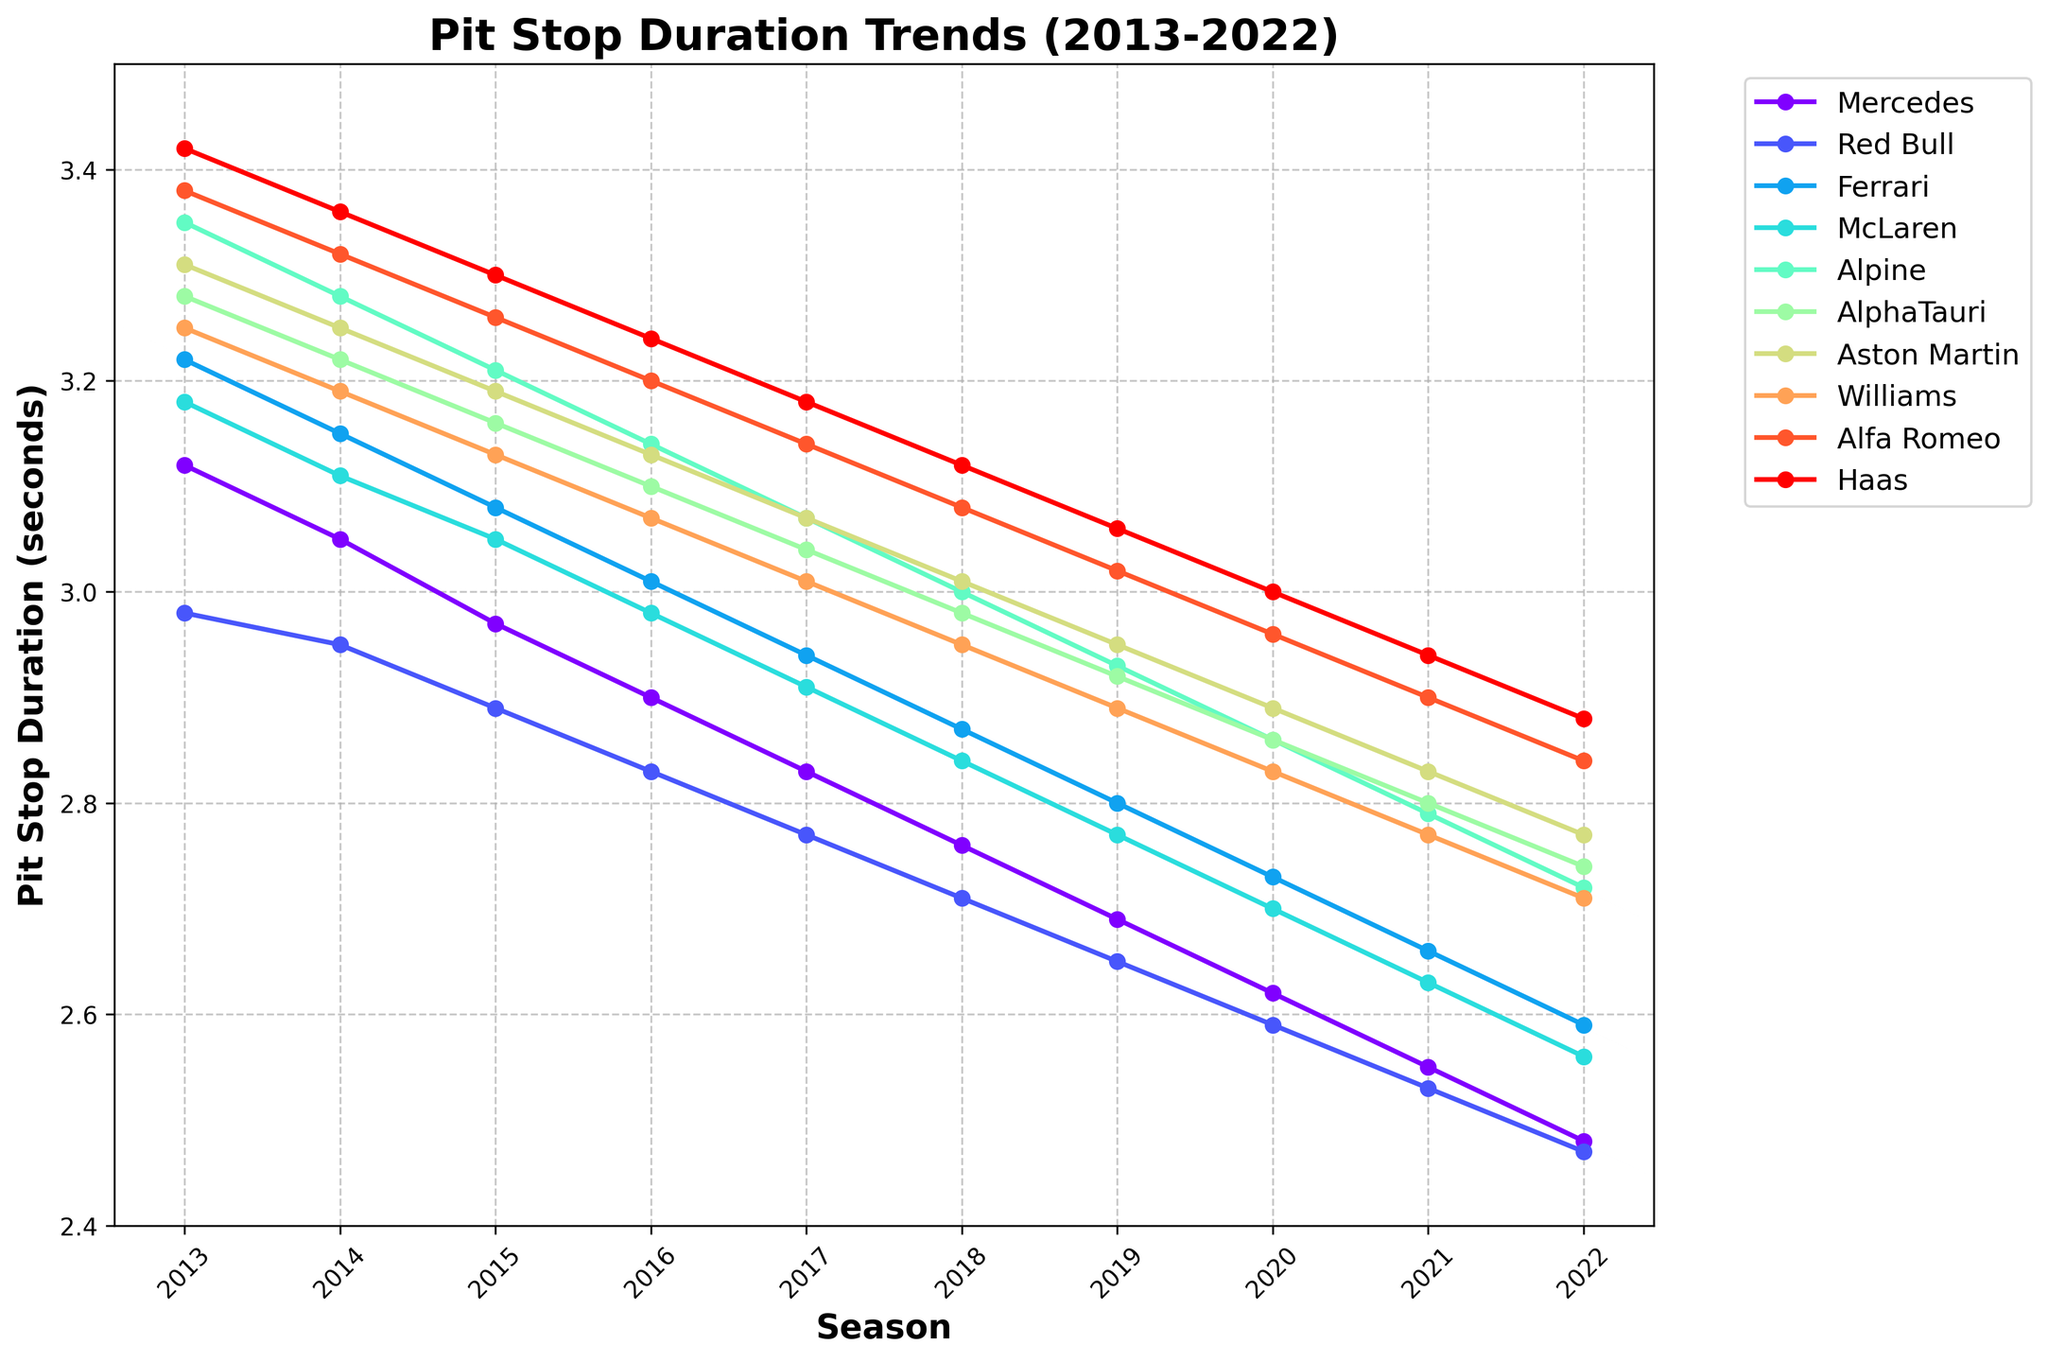Which team had the fastest pit stop duration in 2022? The fastest pit stop duration is identified by the lowest value in 2022. By examining the last entries for each team, it's clear that Red Bull has the lowest value of 2.47 seconds.
Answer: Red Bull How did Ferrari's pit stop duration change from 2013 to 2022? To find the change, subtract Ferrari's 2022 pit stop duration from its 2013 pit stop duration: 3.22 - 2.59 = 0.63 seconds.
Answer: 0.63 seconds Which team showed the greatest improvement in pit stop duration over the 10 seasons? Improvement is measured by the decrease in pit stop duration from 2013 to 2022. Calculate the difference for each team and find the largest: 
Mercedes: 3.12 - 2.48 = 0.64
Red Bull: 2.98 - 2.47 = 0.51
Ferrari: 3.22 - 2.59 = 0.63
McLaren: 3.18 - 2.56 = 0.62
Alpine: 3.35 - 2.72 = 0.63
AlphaTauri: 3.28 - 2.74 = 0.54
Aston Martin: 3.31 - 2.77 = 0.54
Williams: 3.25 - 2.71 = 0.54
Alfa Romeo: 3.38 - 2.84 = 0.54
Haas: 3.42 - 2.88 = 0.54
Mercedes has the highest reduction.
Answer: Mercedes In which season did Red Bull overtake Mercedes for the fastest pit stop duration? By following the lines for Red Bull and Mercedes, note the point at which Red Bull's value becomes consistently lower than that of Mercedes. This occurs from the 2015 season onwards.
Answer: 2015 Which two teams had the closest pit stop durations in 2019? To determine the closest durations, compare and find the smallest difference between pairs for 2019: 
Mercedes & Red Bull: 2.69 - 2.65 = 0.04
Mercedes & Ferrari: 2.69 - 2.80 = 0.11
Ferrari & Red Bull: 2.80 - 2.65 = 0.15
(Similarly for other pairs)
The smallest difference is between Mercedes and Red Bull.
Answer: Mercedes and Red Bull What was the average pit stop duration for McLaren over the 10 seasons? Sum McLaren’s pit stop durations from 2013 to 2022 and divide by 10: (3.18 + 3.11 + 3.05 + 2.98 + 2.91 + 2.84 + 2.77 + 2.70 + 2.63 + 2.56) / 10 = 2.973
Answer: 2.973 seconds Which team had the least variation in pit stop duration over the seasons? The team with the smallest range of values has the least variation. Calculate the range (max - min) for each team over 10 seasons. The smallest value is for Red Bull:
Mercedes: 3.12 - 2.48 = 0.64
Red Bull: 2.98 - 2.47 = 0.51
Ferrari: 3.22 - 2.59 = 0.63
McLaren: 3.18 - 2.56 = 0.62
Alpine: 3.35 - 2.72 = 0.63
AlphaTauri: 3.28 - 2.74 = 0.54
Aston Martin: 3.31 - 2.77 = 0.54
Williams: 3.25 - 2.71 = 0.54
Alfa Romeo: 3.38 - 2.84 = 0.54
Haas: 3.42 - 2.88 = 0.54
Red Bull has the smallest range.
Answer: Red Bull By how many seconds did Haas improve from 2013 to 2022? Calculate the difference between Haas' pit stop durations in 2013 and 2022: 3.42 - 2.88 = 0.54 seconds.
Answer: 0.54 seconds 